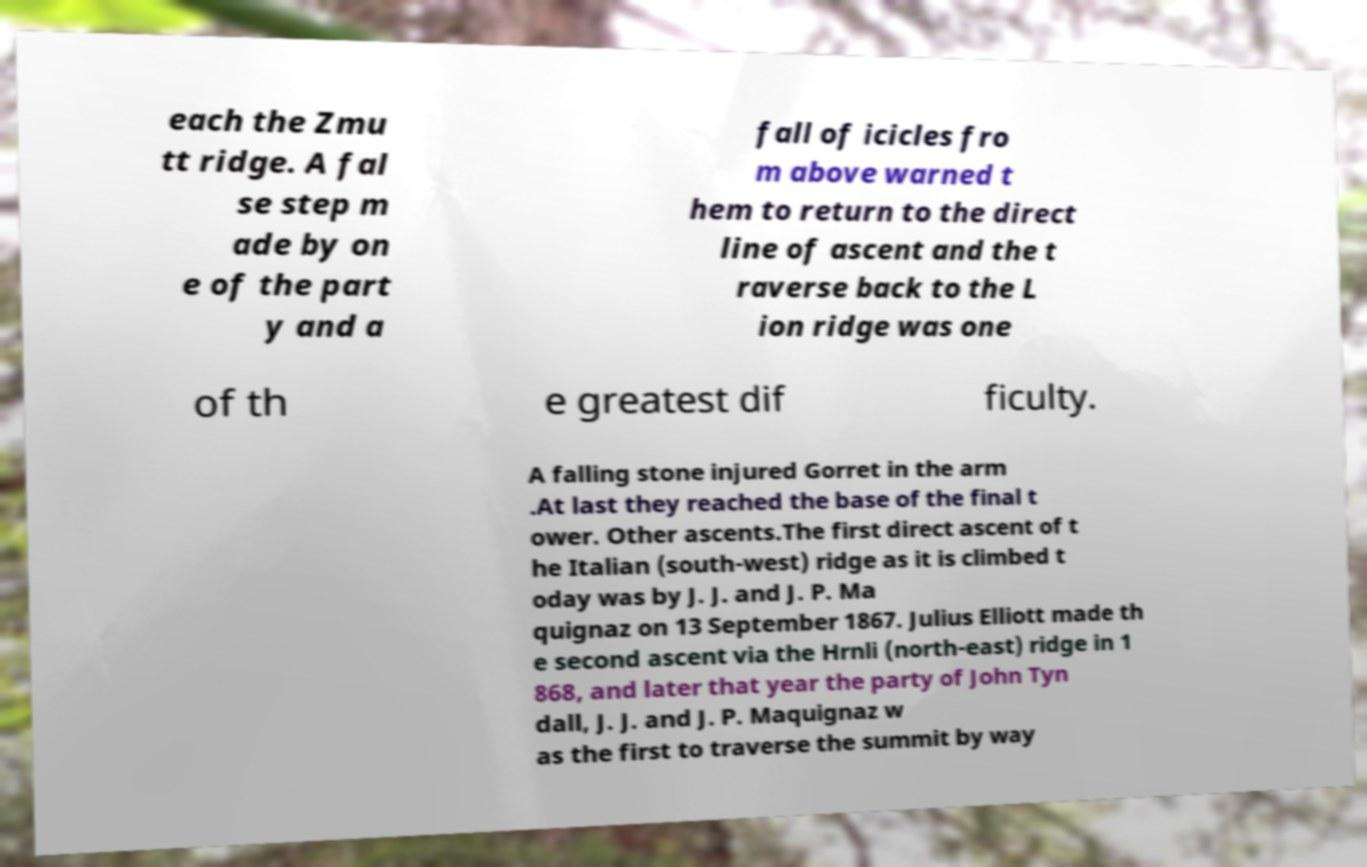For documentation purposes, I need the text within this image transcribed. Could you provide that? each the Zmu tt ridge. A fal se step m ade by on e of the part y and a fall of icicles fro m above warned t hem to return to the direct line of ascent and the t raverse back to the L ion ridge was one of th e greatest dif ficulty. A falling stone injured Gorret in the arm .At last they reached the base of the final t ower. Other ascents.The first direct ascent of t he Italian (south-west) ridge as it is climbed t oday was by J. J. and J. P. Ma quignaz on 13 September 1867. Julius Elliott made th e second ascent via the Hrnli (north-east) ridge in 1 868, and later that year the party of John Tyn dall, J. J. and J. P. Maquignaz w as the first to traverse the summit by way 